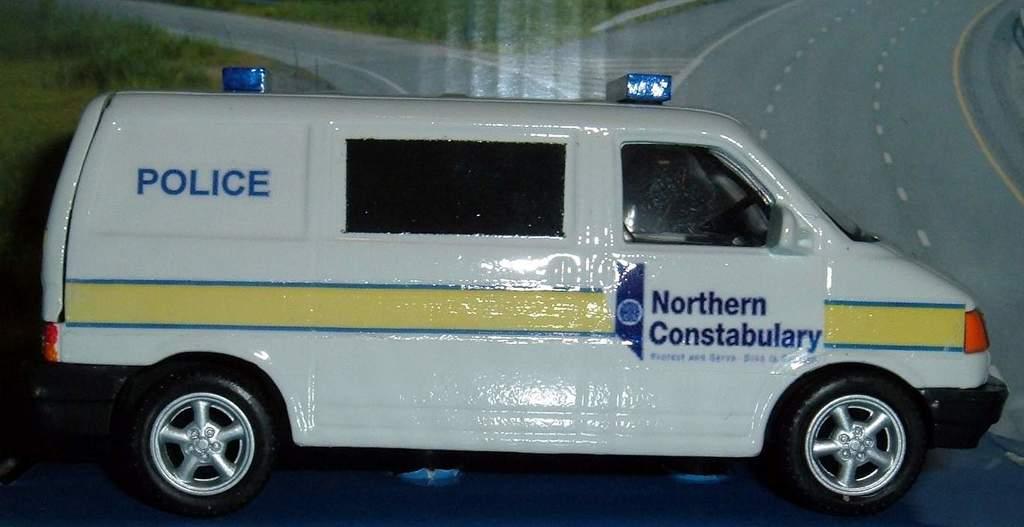What kind of vehicle is this?
Keep it short and to the point. Police. Is this van from northern or southern?
Give a very brief answer. Northern. 